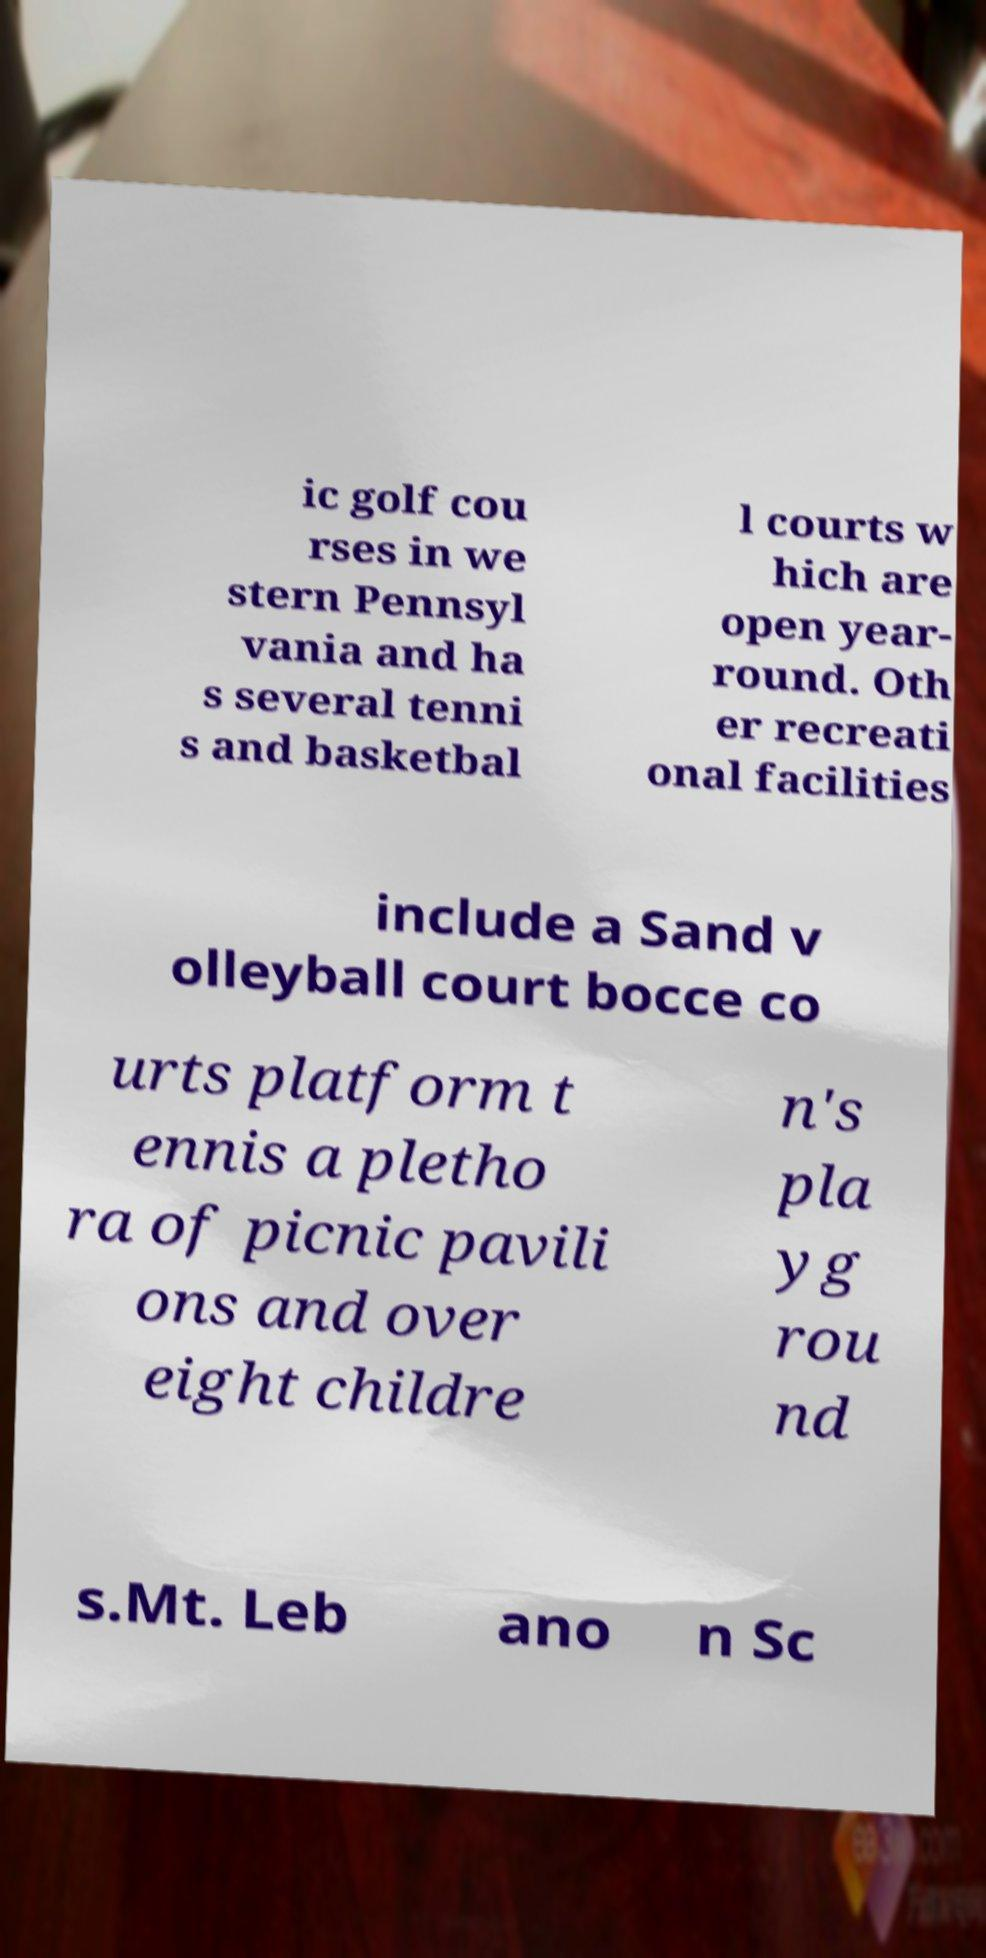There's text embedded in this image that I need extracted. Can you transcribe it verbatim? ic golf cou rses in we stern Pennsyl vania and ha s several tenni s and basketbal l courts w hich are open year- round. Oth er recreati onal facilities include a Sand v olleyball court bocce co urts platform t ennis a pletho ra of picnic pavili ons and over eight childre n's pla yg rou nd s.Mt. Leb ano n Sc 